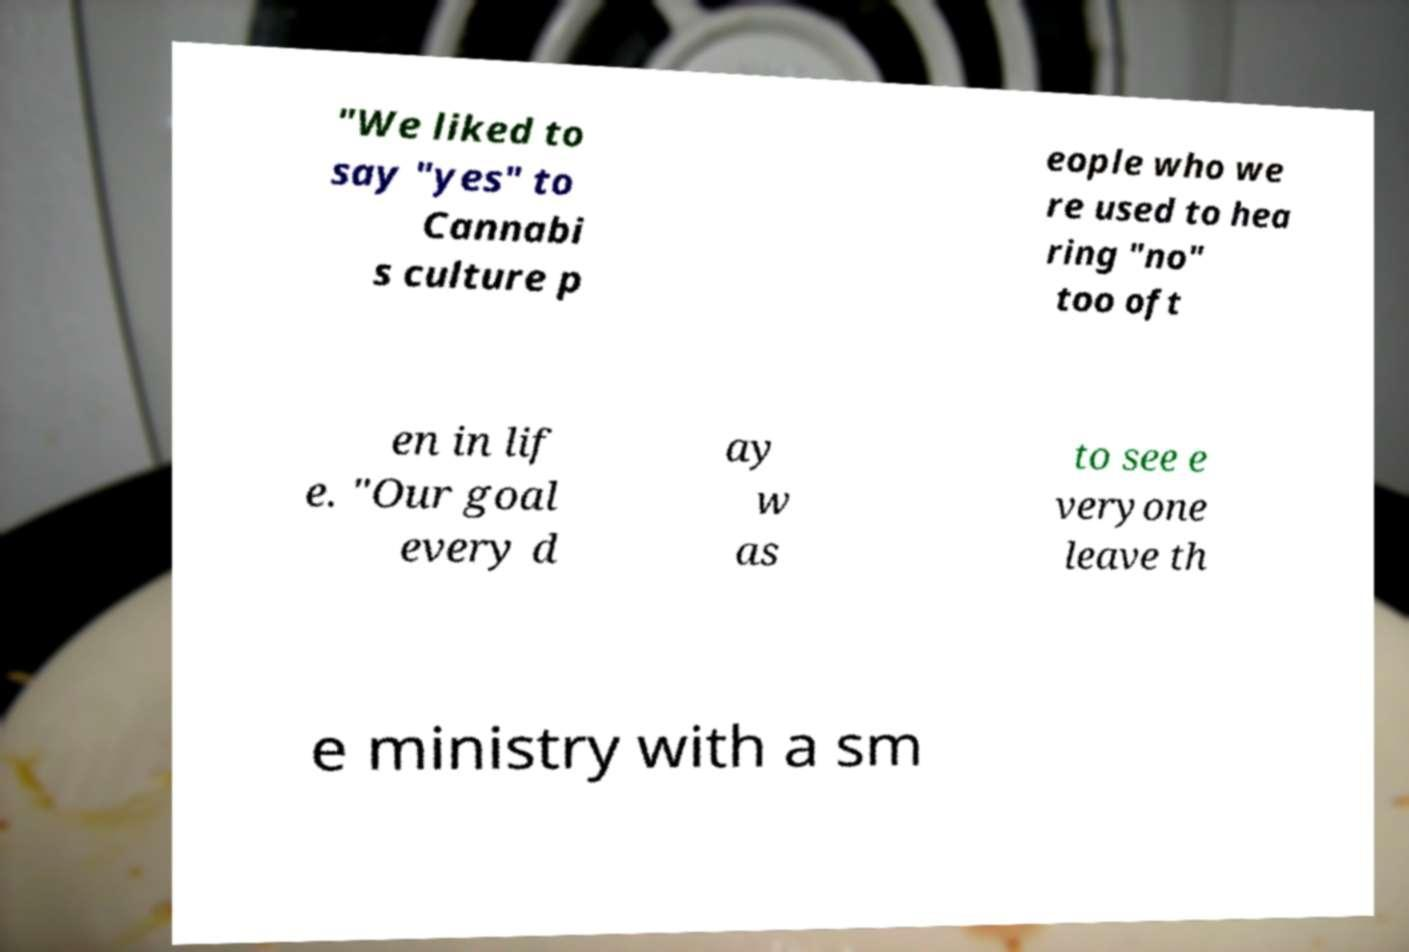I need the written content from this picture converted into text. Can you do that? "We liked to say "yes" to Cannabi s culture p eople who we re used to hea ring "no" too oft en in lif e. "Our goal every d ay w as to see e veryone leave th e ministry with a sm 